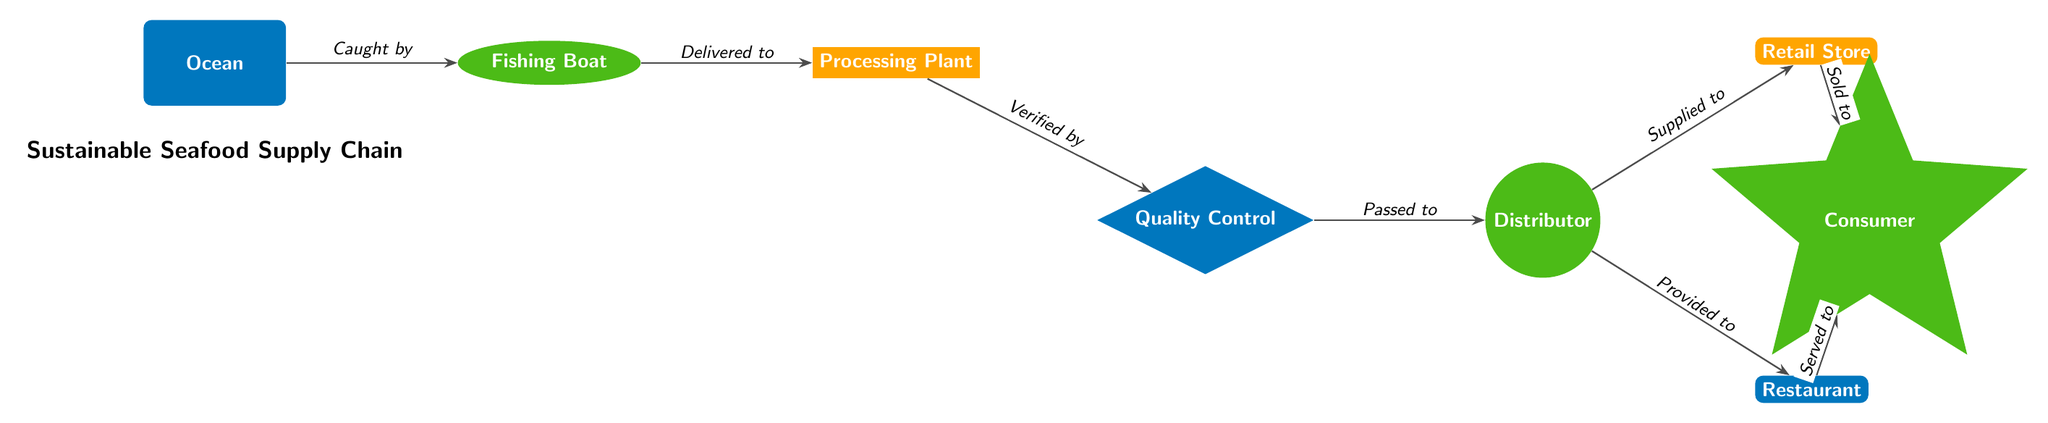What is the first node in the supply chain? The diagram starts with the "Ocean" node, which is depicted on the far left. This is where the seafood is initially caught before moving through the supply chain.
Answer: Ocean How many nodes are in the seafood supply chain? By counting the different elements in the diagram, we can identify seven distinct nodes: Ocean, Fishing Boat, Processing Plant, Quality Control, Distributor, Retail Store, Restaurant, and Consumer. Therefore, the total number of nodes is eight.
Answer: 8 What is the relationship between the Fishing Boat and the Processing Plant? According to the diagram, the Fishing Boat delivers the catch to the Processing Plant. This is represented by the directed edge connecting the two nodes, with the label "Delivered to" indicating the flow from one to the other.
Answer: Delivered to Which node is directly after the Quality Control node? The node following Quality Control in the supply chain is Distributor. This can be deduced by analyzing the direction of the arrows leading from Quality Control to the next node in the sequence.
Answer: Distributor What labels are associated with the edges leading from the Distributor node? There are two outgoing edges from the Distributor node. One edge is labeled "Supplied to" which connects to the Retail Store, and the other edge is labeled "Provided to" which connects to the Restaurant. This shows that the Distributor supplies and provides to two different nodes.
Answer: Supplied to, Provided to What happens to the seafood after it is caught? After the seafood is caught in the Ocean, it is transferred to the Fishing Boat, which is the next step in the chain. This connection is represented as an edge from the Ocean to the Fishing Boat, labeled with "Caught by," indicating the flow of the seafood.
Answer: Delivered to Processing Plant Which node serves seafood to the Consumer? The Consumer receives seafood from both the Retail Store and the Restaurant, as indicated by the two outgoing edges from these nodes leading to the Consumer. This shows that both venues ultimately serve the seafood to the Consumer.
Answer: Retail Store, Restaurant What color represents the Processing Plant in the diagram? The Processing Plant is represented using the color sunny orange. Each node has a specific color to visually distinguish different roles in the supply chain, and the Processing Plant's color is easily identifiable.
Answer: Sunny orange 